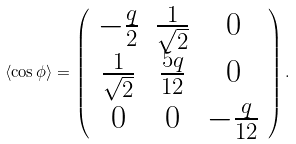Convert formula to latex. <formula><loc_0><loc_0><loc_500><loc_500>\langle \cos { \phi } \rangle = \left ( \begin{array} { c c c } - \frac { q } { 2 } & \frac { 1 } { \sqrt { 2 } } & 0 \\ \frac { 1 } { \sqrt { 2 } } & \frac { 5 q } { 1 2 } & 0 \\ 0 & 0 & - \frac { q } { 1 2 } \end{array} \right ) .</formula> 